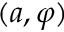<formula> <loc_0><loc_0><loc_500><loc_500>( a , \varphi )</formula> 